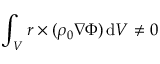<formula> <loc_0><loc_0><loc_500><loc_500>\int _ { V } r \times ( \rho _ { 0 } \nabla \Phi ) \, d V \neq 0</formula> 